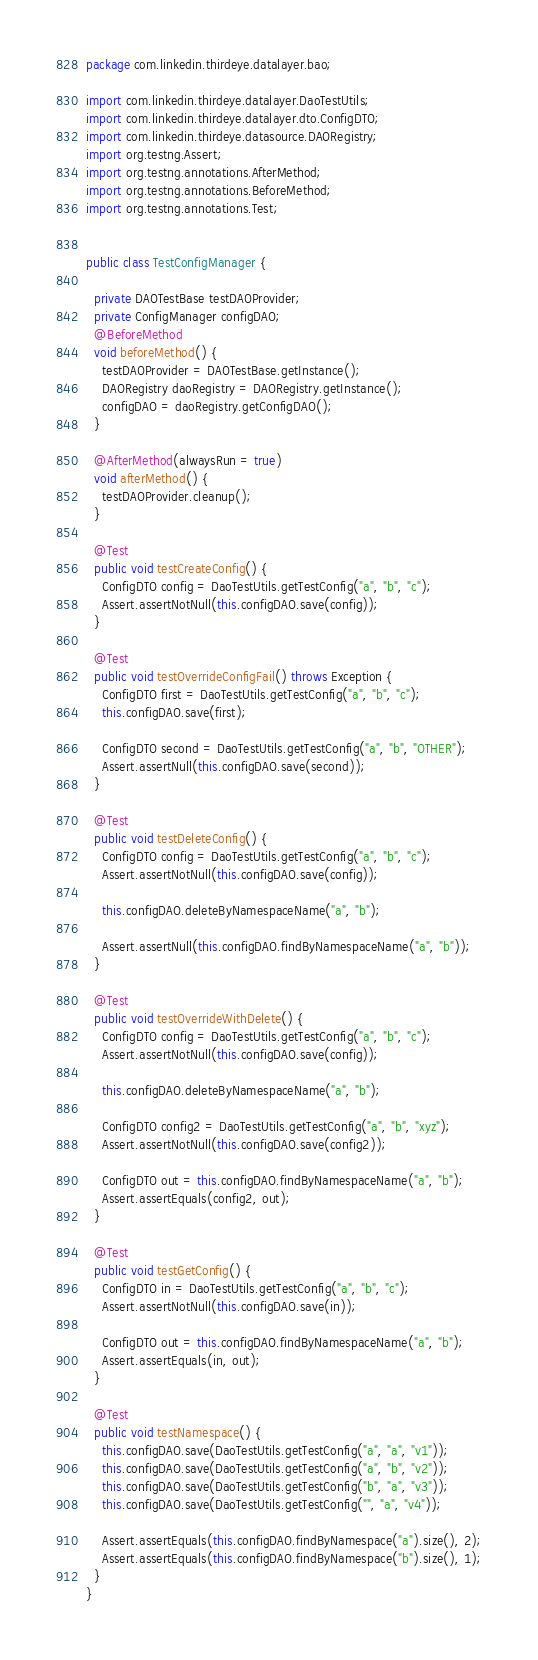Convert code to text. <code><loc_0><loc_0><loc_500><loc_500><_Java_>package com.linkedin.thirdeye.datalayer.bao;

import com.linkedin.thirdeye.datalayer.DaoTestUtils;
import com.linkedin.thirdeye.datalayer.dto.ConfigDTO;
import com.linkedin.thirdeye.datasource.DAORegistry;
import org.testng.Assert;
import org.testng.annotations.AfterMethod;
import org.testng.annotations.BeforeMethod;
import org.testng.annotations.Test;


public class TestConfigManager {

  private DAOTestBase testDAOProvider;
  private ConfigManager configDAO;
  @BeforeMethod
  void beforeMethod() {
    testDAOProvider = DAOTestBase.getInstance();
    DAORegistry daoRegistry = DAORegistry.getInstance();
    configDAO = daoRegistry.getConfigDAO();
  }

  @AfterMethod(alwaysRun = true)
  void afterMethod() {
    testDAOProvider.cleanup();
  }

  @Test
  public void testCreateConfig() {
    ConfigDTO config = DaoTestUtils.getTestConfig("a", "b", "c");
    Assert.assertNotNull(this.configDAO.save(config));
  }

  @Test
  public void testOverrideConfigFail() throws Exception {
    ConfigDTO first = DaoTestUtils.getTestConfig("a", "b", "c");
    this.configDAO.save(first);

    ConfigDTO second = DaoTestUtils.getTestConfig("a", "b", "OTHER");
    Assert.assertNull(this.configDAO.save(second));
  }

  @Test
  public void testDeleteConfig() {
    ConfigDTO config = DaoTestUtils.getTestConfig("a", "b", "c");
    Assert.assertNotNull(this.configDAO.save(config));

    this.configDAO.deleteByNamespaceName("a", "b");

    Assert.assertNull(this.configDAO.findByNamespaceName("a", "b"));
  }

  @Test
  public void testOverrideWithDelete() {
    ConfigDTO config = DaoTestUtils.getTestConfig("a", "b", "c");
    Assert.assertNotNull(this.configDAO.save(config));

    this.configDAO.deleteByNamespaceName("a", "b");

    ConfigDTO config2 = DaoTestUtils.getTestConfig("a", "b", "xyz");
    Assert.assertNotNull(this.configDAO.save(config2));

    ConfigDTO out = this.configDAO.findByNamespaceName("a", "b");
    Assert.assertEquals(config2, out);
  }

  @Test
  public void testGetConfig() {
    ConfigDTO in = DaoTestUtils.getTestConfig("a", "b", "c");
    Assert.assertNotNull(this.configDAO.save(in));

    ConfigDTO out = this.configDAO.findByNamespaceName("a", "b");
    Assert.assertEquals(in, out);
  }

  @Test
  public void testNamespace() {
    this.configDAO.save(DaoTestUtils.getTestConfig("a", "a", "v1"));
    this.configDAO.save(DaoTestUtils.getTestConfig("a", "b", "v2"));
    this.configDAO.save(DaoTestUtils.getTestConfig("b", "a", "v3"));
    this.configDAO.save(DaoTestUtils.getTestConfig("", "a", "v4"));

    Assert.assertEquals(this.configDAO.findByNamespace("a").size(), 2);
    Assert.assertEquals(this.configDAO.findByNamespace("b").size(), 1);
  }
}
</code> 